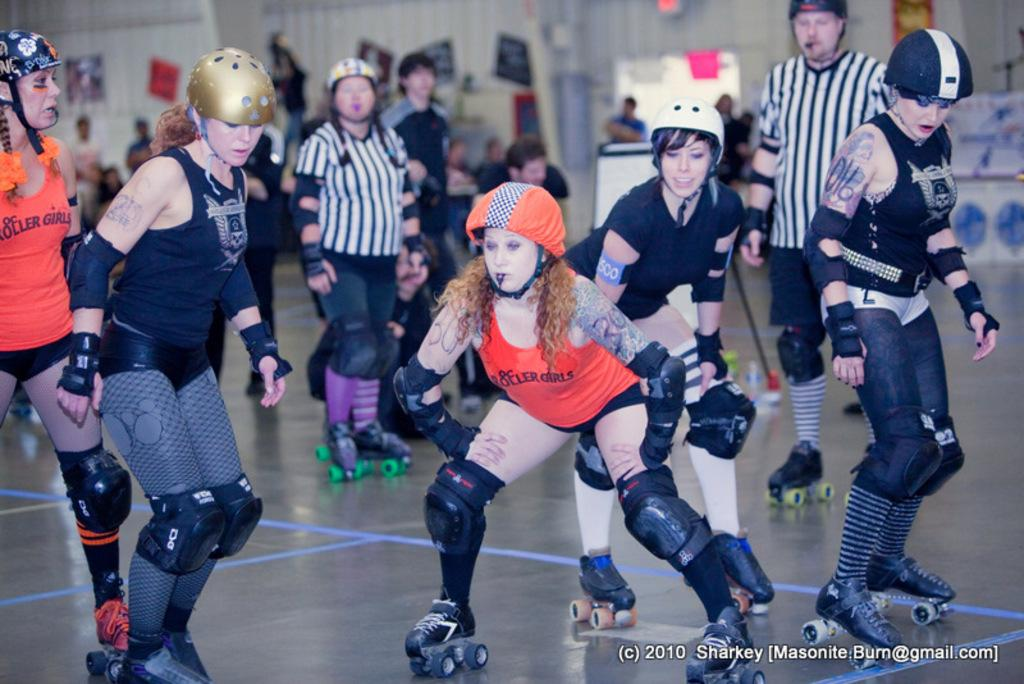How many women are in the image? There are six women in the image. What are the women wearing on their heads? The women are wearing helmets. What activity are the women engaged in? The women are skating. Are there any spectators in the image? Yes, there are people watching the women skate. What can be seen in the background of the image? There is a white wall in the background, with many posters and charts pasted on it. What type of thunder can be heard during the women's lunch break in the image? There is no mention of thunder or lunch in the image, so it cannot be determined if any thunder is heard during a lunch break. 